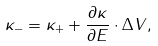Convert formula to latex. <formula><loc_0><loc_0><loc_500><loc_500>\kappa _ { - } = \kappa _ { + } + \frac { \partial \kappa } { \partial E } \cdot \Delta V ,</formula> 